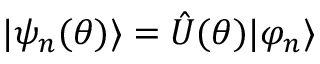<formula> <loc_0><loc_0><loc_500><loc_500>| \psi _ { n } ( \theta ) \rangle = \hat { U } ( \theta ) | \varphi _ { n } \rangle</formula> 